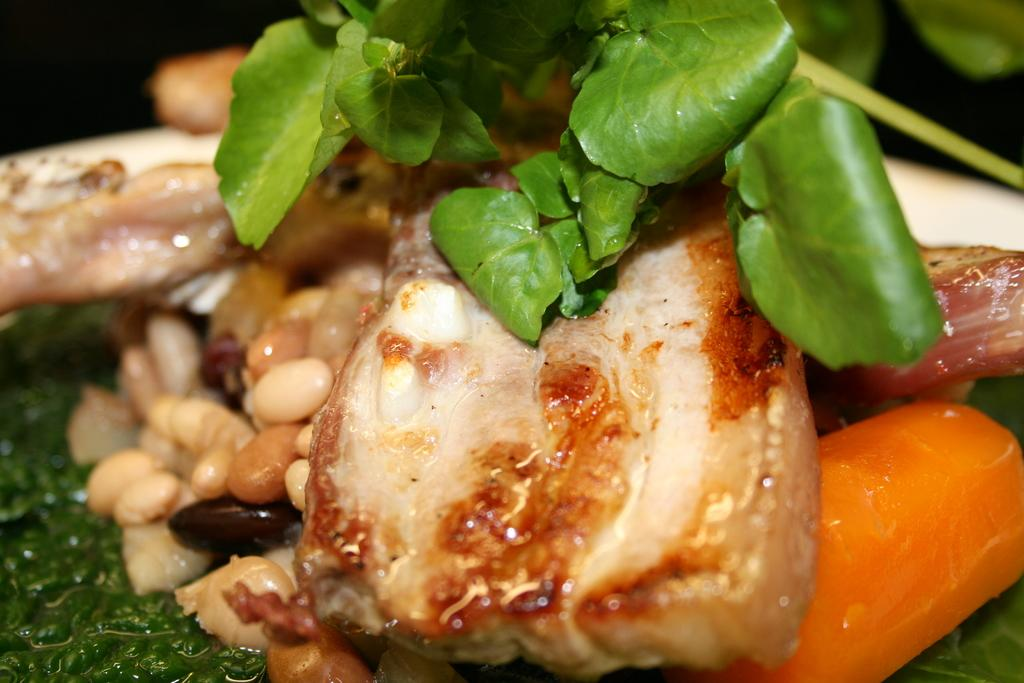What type of objects can be seen in the image? There are food items in the image. What is placed on top of the food items? Leaves are placed on top of the food items. What type of hill can be seen in the image? There is no hill present in the image; it features food items with leaves on top. Can you tell me how many pockets are visible in the image? There are no pockets visible in the image. 